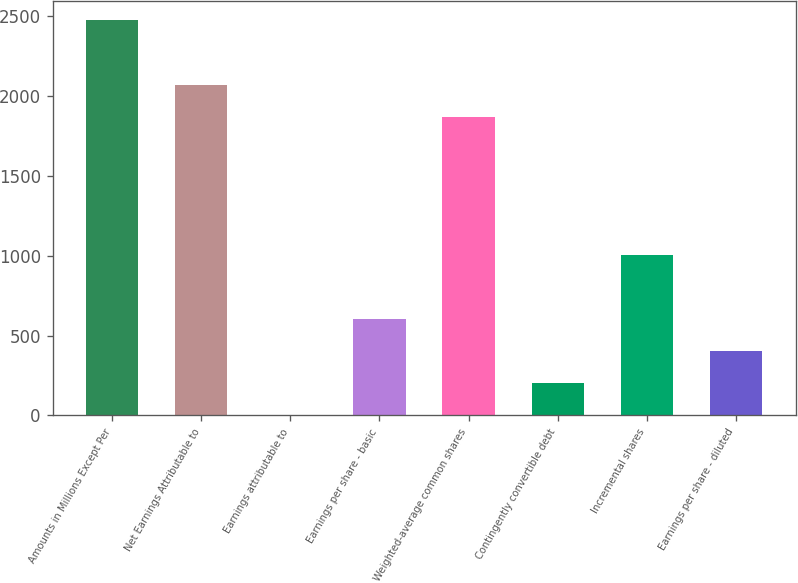Convert chart to OTSL. <chart><loc_0><loc_0><loc_500><loc_500><bar_chart><fcel>Amounts in Millions Except Per<fcel>Net Earnings Attributable to<fcel>Earnings attributable to<fcel>Earnings per share - basic<fcel>Weighted-average common shares<fcel>Contingently convertible debt<fcel>Incremental shares<fcel>Earnings per share - diluted<nl><fcel>2474.4<fcel>2072.2<fcel>1<fcel>604.3<fcel>1871.1<fcel>202.1<fcel>1006.5<fcel>403.2<nl></chart> 